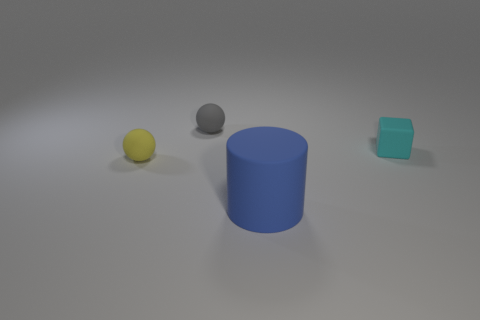Subtract all yellow cubes. Subtract all blue cylinders. How many cubes are left? 1 Add 2 tiny cyan objects. How many tiny cyan objects are left? 3 Add 4 tiny gray spheres. How many tiny gray spheres exist? 5 Add 1 gray spheres. How many objects exist? 5 Subtract 0 yellow cylinders. How many objects are left? 4 Subtract all cylinders. How many objects are left? 3 Subtract 1 spheres. How many spheres are left? 1 Subtract all cyan cylinders. How many yellow spheres are left? 1 Subtract all large things. Subtract all tiny gray rubber cylinders. How many objects are left? 3 